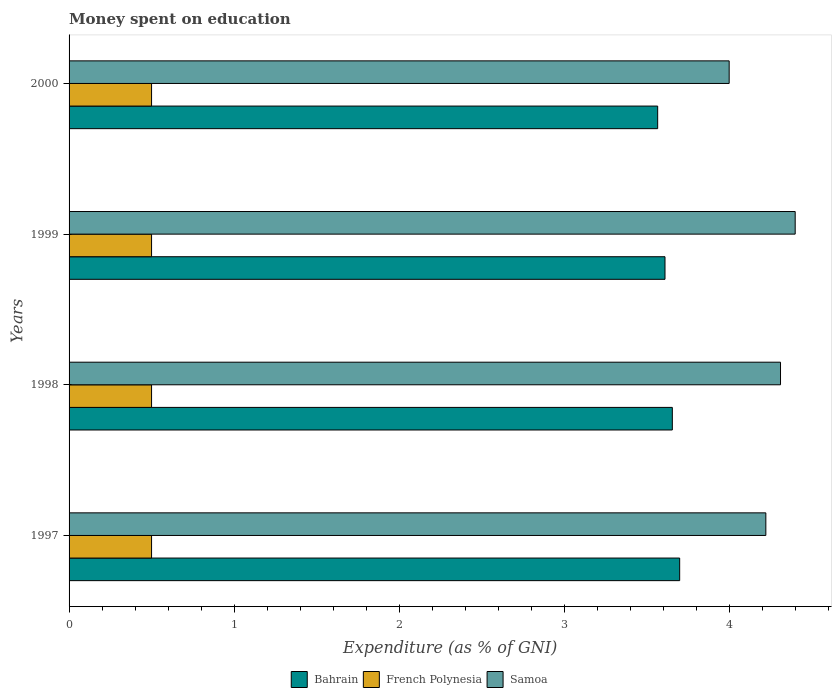How many groups of bars are there?
Provide a short and direct response. 4. How many bars are there on the 1st tick from the bottom?
Offer a terse response. 3. What is the label of the 3rd group of bars from the top?
Your response must be concise. 1998. What is the amount of money spent on education in French Polynesia in 2000?
Make the answer very short. 0.5. Across all years, what is the minimum amount of money spent on education in Bahrain?
Your answer should be very brief. 3.57. In which year was the amount of money spent on education in Samoa maximum?
Offer a very short reply. 1999. What is the total amount of money spent on education in French Polynesia in the graph?
Make the answer very short. 2. What is the difference between the amount of money spent on education in Samoa in 1997 and that in 2000?
Your response must be concise. 0.22. What is the difference between the amount of money spent on education in French Polynesia in 2000 and the amount of money spent on education in Samoa in 1997?
Provide a short and direct response. -3.72. What is the average amount of money spent on education in Samoa per year?
Offer a terse response. 4.23. In the year 2000, what is the difference between the amount of money spent on education in Bahrain and amount of money spent on education in French Polynesia?
Offer a terse response. 3.07. What is the ratio of the amount of money spent on education in Samoa in 1998 to that in 2000?
Ensure brevity in your answer.  1.08. What is the difference between the highest and the second highest amount of money spent on education in Samoa?
Ensure brevity in your answer.  0.09. What does the 3rd bar from the top in 1998 represents?
Make the answer very short. Bahrain. What does the 2nd bar from the bottom in 2000 represents?
Keep it short and to the point. French Polynesia. How many bars are there?
Offer a very short reply. 12. Are all the bars in the graph horizontal?
Your answer should be compact. Yes. What is the difference between two consecutive major ticks on the X-axis?
Your answer should be very brief. 1. Does the graph contain any zero values?
Your response must be concise. No. How many legend labels are there?
Provide a short and direct response. 3. How are the legend labels stacked?
Make the answer very short. Horizontal. What is the title of the graph?
Keep it short and to the point. Money spent on education. What is the label or title of the X-axis?
Your response must be concise. Expenditure (as % of GNI). What is the label or title of the Y-axis?
Keep it short and to the point. Years. What is the Expenditure (as % of GNI) in Bahrain in 1997?
Your answer should be compact. 3.7. What is the Expenditure (as % of GNI) in French Polynesia in 1997?
Give a very brief answer. 0.5. What is the Expenditure (as % of GNI) of Samoa in 1997?
Keep it short and to the point. 4.22. What is the Expenditure (as % of GNI) in Bahrain in 1998?
Your answer should be compact. 3.66. What is the Expenditure (as % of GNI) of French Polynesia in 1998?
Your response must be concise. 0.5. What is the Expenditure (as % of GNI) in Samoa in 1998?
Your response must be concise. 4.31. What is the Expenditure (as % of GNI) of Bahrain in 1999?
Your response must be concise. 3.61. What is the Expenditure (as % of GNI) in French Polynesia in 1999?
Give a very brief answer. 0.5. What is the Expenditure (as % of GNI) in Samoa in 1999?
Keep it short and to the point. 4.4. What is the Expenditure (as % of GNI) of Bahrain in 2000?
Give a very brief answer. 3.57. What is the Expenditure (as % of GNI) in French Polynesia in 2000?
Ensure brevity in your answer.  0.5. What is the Expenditure (as % of GNI) of Samoa in 2000?
Your answer should be compact. 4. Across all years, what is the maximum Expenditure (as % of GNI) in Bahrain?
Give a very brief answer. 3.7. Across all years, what is the maximum Expenditure (as % of GNI) in French Polynesia?
Keep it short and to the point. 0.5. Across all years, what is the minimum Expenditure (as % of GNI) in Bahrain?
Keep it short and to the point. 3.57. Across all years, what is the minimum Expenditure (as % of GNI) in French Polynesia?
Your answer should be very brief. 0.5. Across all years, what is the minimum Expenditure (as % of GNI) of Samoa?
Make the answer very short. 4. What is the total Expenditure (as % of GNI) of Bahrain in the graph?
Offer a terse response. 14.53. What is the total Expenditure (as % of GNI) of French Polynesia in the graph?
Offer a very short reply. 2. What is the total Expenditure (as % of GNI) of Samoa in the graph?
Keep it short and to the point. 16.93. What is the difference between the Expenditure (as % of GNI) of Bahrain in 1997 and that in 1998?
Offer a terse response. 0.04. What is the difference between the Expenditure (as % of GNI) in Samoa in 1997 and that in 1998?
Offer a terse response. -0.09. What is the difference between the Expenditure (as % of GNI) of Bahrain in 1997 and that in 1999?
Ensure brevity in your answer.  0.09. What is the difference between the Expenditure (as % of GNI) in Samoa in 1997 and that in 1999?
Ensure brevity in your answer.  -0.18. What is the difference between the Expenditure (as % of GNI) in Bahrain in 1997 and that in 2000?
Give a very brief answer. 0.13. What is the difference between the Expenditure (as % of GNI) of Samoa in 1997 and that in 2000?
Provide a short and direct response. 0.22. What is the difference between the Expenditure (as % of GNI) of Bahrain in 1998 and that in 1999?
Offer a very short reply. 0.04. What is the difference between the Expenditure (as % of GNI) of Samoa in 1998 and that in 1999?
Provide a succinct answer. -0.09. What is the difference between the Expenditure (as % of GNI) of Bahrain in 1998 and that in 2000?
Provide a short and direct response. 0.09. What is the difference between the Expenditure (as % of GNI) of French Polynesia in 1998 and that in 2000?
Your response must be concise. 0. What is the difference between the Expenditure (as % of GNI) of Samoa in 1998 and that in 2000?
Ensure brevity in your answer.  0.31. What is the difference between the Expenditure (as % of GNI) of Bahrain in 1999 and that in 2000?
Offer a very short reply. 0.04. What is the difference between the Expenditure (as % of GNI) in Bahrain in 1997 and the Expenditure (as % of GNI) in French Polynesia in 1998?
Make the answer very short. 3.2. What is the difference between the Expenditure (as % of GNI) of Bahrain in 1997 and the Expenditure (as % of GNI) of Samoa in 1998?
Your answer should be compact. -0.61. What is the difference between the Expenditure (as % of GNI) in French Polynesia in 1997 and the Expenditure (as % of GNI) in Samoa in 1998?
Give a very brief answer. -3.81. What is the difference between the Expenditure (as % of GNI) of Bahrain in 1997 and the Expenditure (as % of GNI) of French Polynesia in 1999?
Your answer should be very brief. 3.2. What is the difference between the Expenditure (as % of GNI) of Bahrain in 1997 and the Expenditure (as % of GNI) of Samoa in 1999?
Your answer should be compact. -0.7. What is the difference between the Expenditure (as % of GNI) of French Polynesia in 1997 and the Expenditure (as % of GNI) of Samoa in 1999?
Ensure brevity in your answer.  -3.9. What is the difference between the Expenditure (as % of GNI) in Bahrain in 1997 and the Expenditure (as % of GNI) in French Polynesia in 2000?
Provide a succinct answer. 3.2. What is the difference between the Expenditure (as % of GNI) in French Polynesia in 1997 and the Expenditure (as % of GNI) in Samoa in 2000?
Make the answer very short. -3.5. What is the difference between the Expenditure (as % of GNI) in Bahrain in 1998 and the Expenditure (as % of GNI) in French Polynesia in 1999?
Offer a very short reply. 3.16. What is the difference between the Expenditure (as % of GNI) in Bahrain in 1998 and the Expenditure (as % of GNI) in Samoa in 1999?
Give a very brief answer. -0.74. What is the difference between the Expenditure (as % of GNI) of French Polynesia in 1998 and the Expenditure (as % of GNI) of Samoa in 1999?
Your response must be concise. -3.9. What is the difference between the Expenditure (as % of GNI) in Bahrain in 1998 and the Expenditure (as % of GNI) in French Polynesia in 2000?
Your response must be concise. 3.16. What is the difference between the Expenditure (as % of GNI) in Bahrain in 1998 and the Expenditure (as % of GNI) in Samoa in 2000?
Ensure brevity in your answer.  -0.34. What is the difference between the Expenditure (as % of GNI) of French Polynesia in 1998 and the Expenditure (as % of GNI) of Samoa in 2000?
Offer a terse response. -3.5. What is the difference between the Expenditure (as % of GNI) in Bahrain in 1999 and the Expenditure (as % of GNI) in French Polynesia in 2000?
Make the answer very short. 3.11. What is the difference between the Expenditure (as % of GNI) in Bahrain in 1999 and the Expenditure (as % of GNI) in Samoa in 2000?
Give a very brief answer. -0.39. What is the difference between the Expenditure (as % of GNI) of French Polynesia in 1999 and the Expenditure (as % of GNI) of Samoa in 2000?
Offer a very short reply. -3.5. What is the average Expenditure (as % of GNI) of Bahrain per year?
Make the answer very short. 3.63. What is the average Expenditure (as % of GNI) in French Polynesia per year?
Keep it short and to the point. 0.5. What is the average Expenditure (as % of GNI) of Samoa per year?
Make the answer very short. 4.23. In the year 1997, what is the difference between the Expenditure (as % of GNI) of Bahrain and Expenditure (as % of GNI) of French Polynesia?
Keep it short and to the point. 3.2. In the year 1997, what is the difference between the Expenditure (as % of GNI) of Bahrain and Expenditure (as % of GNI) of Samoa?
Offer a terse response. -0.52. In the year 1997, what is the difference between the Expenditure (as % of GNI) in French Polynesia and Expenditure (as % of GNI) in Samoa?
Ensure brevity in your answer.  -3.72. In the year 1998, what is the difference between the Expenditure (as % of GNI) of Bahrain and Expenditure (as % of GNI) of French Polynesia?
Offer a very short reply. 3.16. In the year 1998, what is the difference between the Expenditure (as % of GNI) in Bahrain and Expenditure (as % of GNI) in Samoa?
Your answer should be very brief. -0.66. In the year 1998, what is the difference between the Expenditure (as % of GNI) of French Polynesia and Expenditure (as % of GNI) of Samoa?
Your response must be concise. -3.81. In the year 1999, what is the difference between the Expenditure (as % of GNI) of Bahrain and Expenditure (as % of GNI) of French Polynesia?
Offer a terse response. 3.11. In the year 1999, what is the difference between the Expenditure (as % of GNI) of Bahrain and Expenditure (as % of GNI) of Samoa?
Your response must be concise. -0.79. In the year 1999, what is the difference between the Expenditure (as % of GNI) in French Polynesia and Expenditure (as % of GNI) in Samoa?
Offer a terse response. -3.9. In the year 2000, what is the difference between the Expenditure (as % of GNI) of Bahrain and Expenditure (as % of GNI) of French Polynesia?
Provide a short and direct response. 3.07. In the year 2000, what is the difference between the Expenditure (as % of GNI) in Bahrain and Expenditure (as % of GNI) in Samoa?
Keep it short and to the point. -0.43. In the year 2000, what is the difference between the Expenditure (as % of GNI) in French Polynesia and Expenditure (as % of GNI) in Samoa?
Your response must be concise. -3.5. What is the ratio of the Expenditure (as % of GNI) in Bahrain in 1997 to that in 1998?
Provide a succinct answer. 1.01. What is the ratio of the Expenditure (as % of GNI) in French Polynesia in 1997 to that in 1998?
Offer a terse response. 1. What is the ratio of the Expenditure (as % of GNI) in Samoa in 1997 to that in 1998?
Offer a very short reply. 0.98. What is the ratio of the Expenditure (as % of GNI) of Bahrain in 1997 to that in 1999?
Ensure brevity in your answer.  1.02. What is the ratio of the Expenditure (as % of GNI) in French Polynesia in 1997 to that in 1999?
Provide a succinct answer. 1. What is the ratio of the Expenditure (as % of GNI) in Samoa in 1997 to that in 1999?
Ensure brevity in your answer.  0.96. What is the ratio of the Expenditure (as % of GNI) in Bahrain in 1997 to that in 2000?
Your answer should be very brief. 1.04. What is the ratio of the Expenditure (as % of GNI) of French Polynesia in 1997 to that in 2000?
Give a very brief answer. 1. What is the ratio of the Expenditure (as % of GNI) in Samoa in 1997 to that in 2000?
Your answer should be very brief. 1.06. What is the ratio of the Expenditure (as % of GNI) of Bahrain in 1998 to that in 1999?
Offer a terse response. 1.01. What is the ratio of the Expenditure (as % of GNI) of French Polynesia in 1998 to that in 1999?
Offer a very short reply. 1. What is the ratio of the Expenditure (as % of GNI) of Samoa in 1998 to that in 1999?
Your answer should be very brief. 0.98. What is the ratio of the Expenditure (as % of GNI) of Bahrain in 1998 to that in 2000?
Your answer should be compact. 1.02. What is the ratio of the Expenditure (as % of GNI) in French Polynesia in 1998 to that in 2000?
Provide a succinct answer. 1. What is the ratio of the Expenditure (as % of GNI) of Samoa in 1998 to that in 2000?
Offer a very short reply. 1.08. What is the ratio of the Expenditure (as % of GNI) in Bahrain in 1999 to that in 2000?
Offer a very short reply. 1.01. What is the ratio of the Expenditure (as % of GNI) in French Polynesia in 1999 to that in 2000?
Make the answer very short. 1. What is the ratio of the Expenditure (as % of GNI) of Samoa in 1999 to that in 2000?
Give a very brief answer. 1.1. What is the difference between the highest and the second highest Expenditure (as % of GNI) of Bahrain?
Keep it short and to the point. 0.04. What is the difference between the highest and the second highest Expenditure (as % of GNI) of French Polynesia?
Offer a terse response. 0. What is the difference between the highest and the second highest Expenditure (as % of GNI) in Samoa?
Your answer should be very brief. 0.09. What is the difference between the highest and the lowest Expenditure (as % of GNI) in Bahrain?
Make the answer very short. 0.13. What is the difference between the highest and the lowest Expenditure (as % of GNI) of Samoa?
Give a very brief answer. 0.4. 